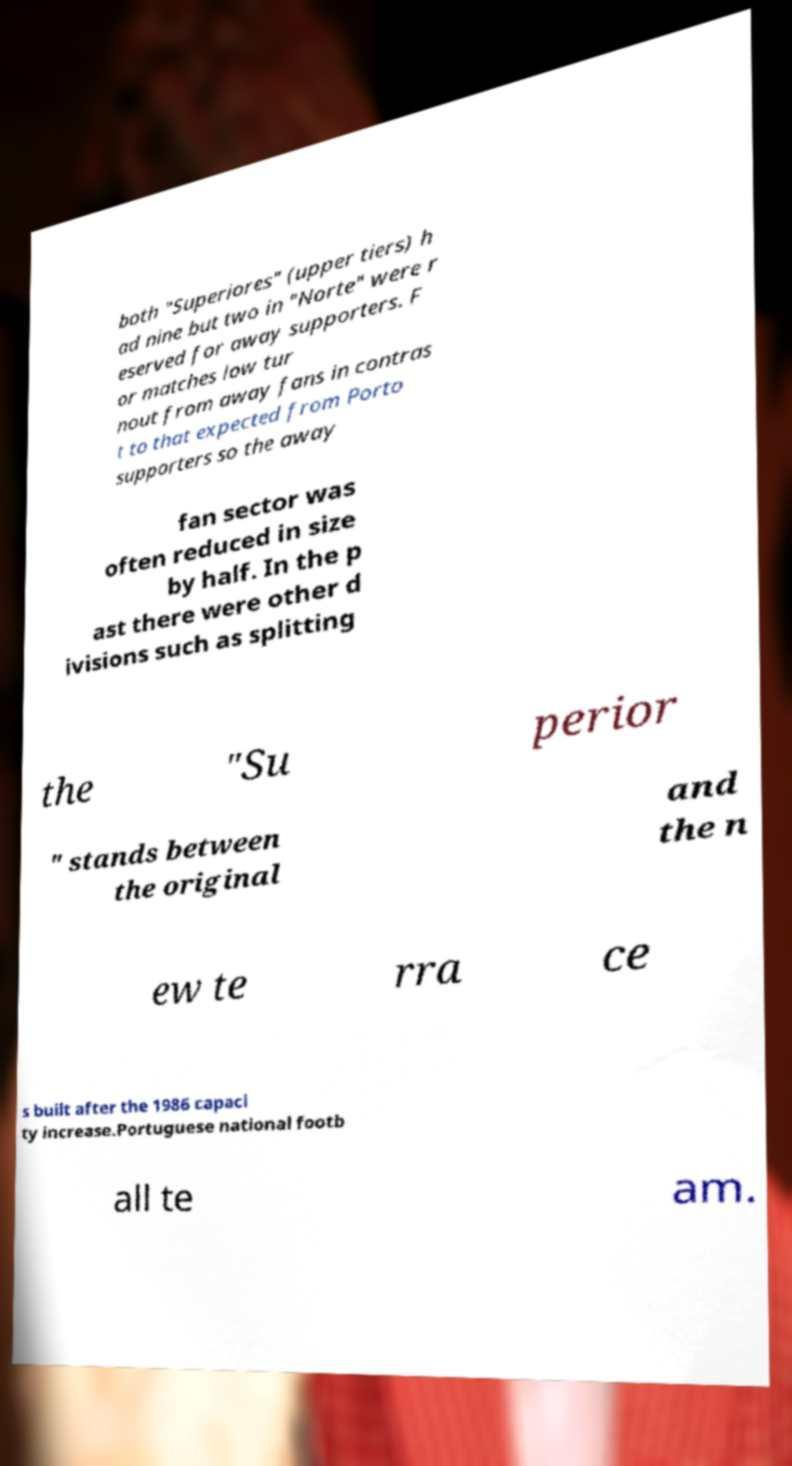For documentation purposes, I need the text within this image transcribed. Could you provide that? both "Superiores" (upper tiers) h ad nine but two in "Norte" were r eserved for away supporters. F or matches low tur nout from away fans in contras t to that expected from Porto supporters so the away fan sector was often reduced in size by half. In the p ast there were other d ivisions such as splitting the "Su perior " stands between the original and the n ew te rra ce s built after the 1986 capaci ty increase.Portuguese national footb all te am. 